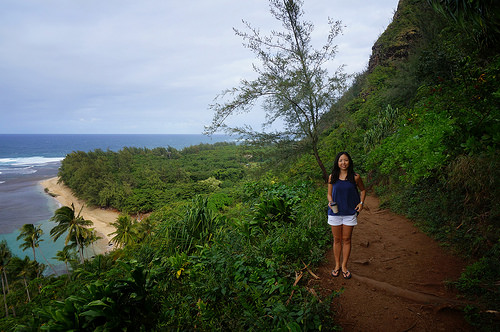<image>
Is the woman to the right of the sea? Yes. From this viewpoint, the woman is positioned to the right side relative to the sea. 